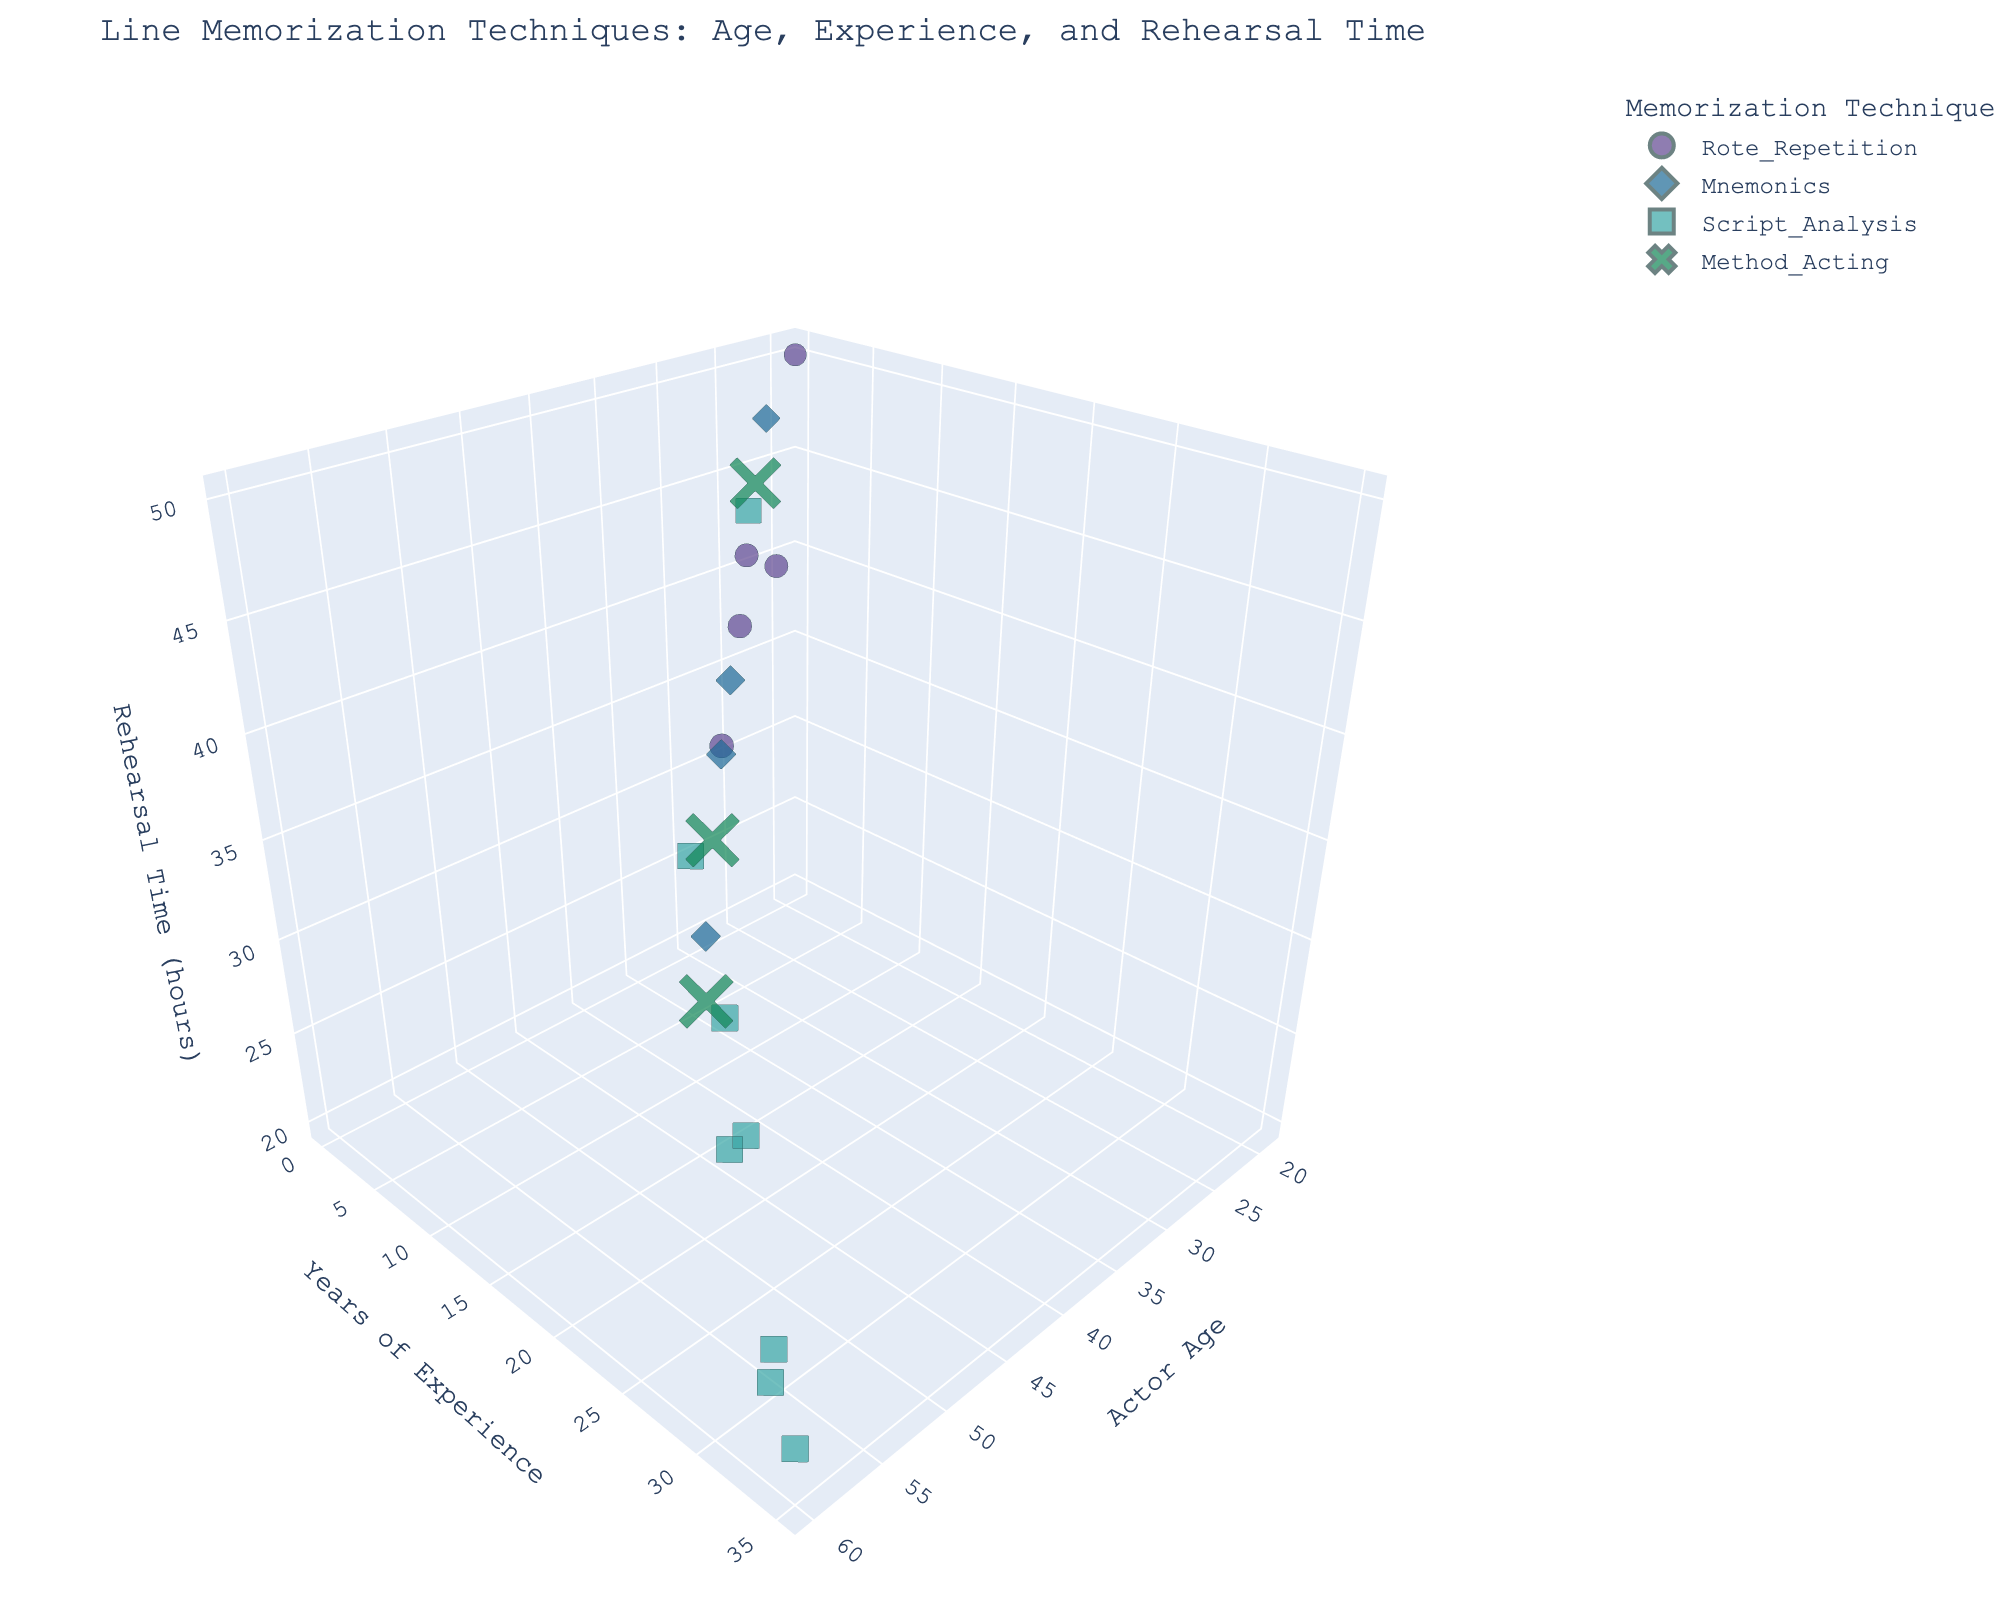What's the title of the figure? The title is usually shown at the top of the figure in larger font. In this case, it clearly states: "Line Memorization Techniques: Age, Experience, and Rehearsal Time".
Answer: Line Memorization Techniques: Age, Experience, and Rehearsal Time What does the z-axis represent? The z-axis is labeled to indicate what variable it represents. Here, the z-axis is labeled as "Rehearsal Time (hours)".
Answer: Rehearsal Time (hours) How many memorization techniques are visualized in the figure? According to the legend, there are different color and symbol representations, each representing a unique technique. By observing the legend, there are five techniques shown.
Answer: Five Which technique is associated with the highest performance accuracy? By looking at the size of the data points as they represent accuracy and identifying the largest marker, we observe the largest marker is for the 'Script_Analysis' technique.
Answer: Script_Analysis What is the average rehearsal time for actors using the "Method_Acting" technique? First locate all data points corresponding to "Method_Acting". The rehearsal times are 25, 45, and 32 hours. Summing these gives 102, dividing by the number of points (3) we get (102/3).
Answer: 34 hours Which age group has the lowest accuracy for the "Rote_Repetition" technique? Identify points related to "Rote_Repetition" and compare accuracy. The lowest accuracy for "Rote_Repetition" is 78%, which belongs to the age 19 group.
Answer: 19 years Compare the average years of experience for actors using "Script_Analysis" and "Mnemonics". Who has more experience on average? Calculate the average experience for each technique. "Script_Analysis" has experiences: 20, 5, 30, 25, 15, 22, 35, 32. "Mnemonics" has experiences: 8, 12, 7, 2. "Script_Analysis" average is 177/8 and "Mnemonics" average is 29/4.
Answer: Script_Analysis What rehearsal time has been most frequently observed for actors using the "Script_Analysis" technique? Identify all rehearsal times for "Script_Analysis": 30, 45, 20, 28, 35, 25, 22, 24. The value 30 appears twice, more than any other value.
Answer: 30 hours Does a higher rehearsal time always correspond to higher performance accuracy for actors aged over 50? Compare the rehearsal times and accuracy levels for actors over 50. Higher rehearsal times range between 22 and 30, with accuracy ranging from 97 to 99, indicating accuracy remains high despite hours reducing.
Answer: No 